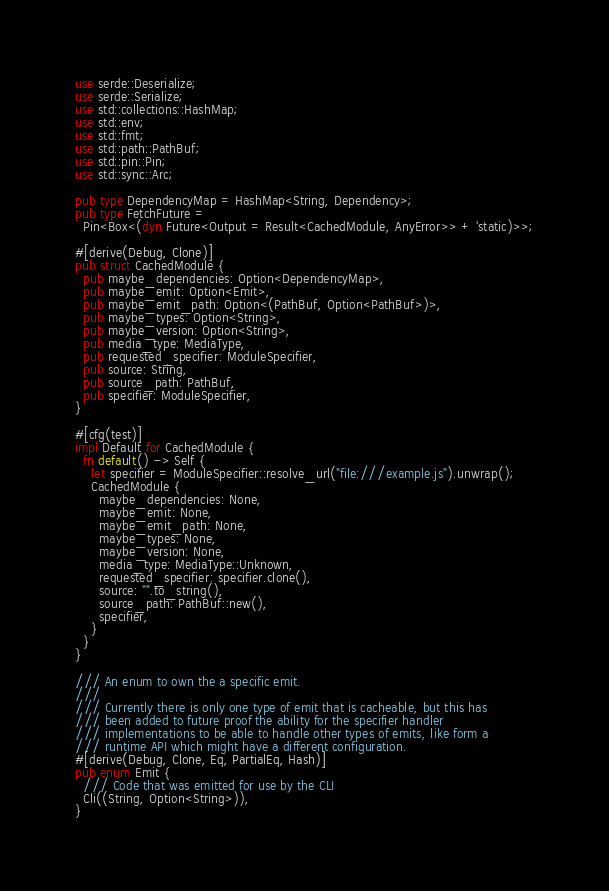Convert code to text. <code><loc_0><loc_0><loc_500><loc_500><_Rust_>use serde::Deserialize;
use serde::Serialize;
use std::collections::HashMap;
use std::env;
use std::fmt;
use std::path::PathBuf;
use std::pin::Pin;
use std::sync::Arc;

pub type DependencyMap = HashMap<String, Dependency>;
pub type FetchFuture =
  Pin<Box<(dyn Future<Output = Result<CachedModule, AnyError>> + 'static)>>;

#[derive(Debug, Clone)]
pub struct CachedModule {
  pub maybe_dependencies: Option<DependencyMap>,
  pub maybe_emit: Option<Emit>,
  pub maybe_emit_path: Option<(PathBuf, Option<PathBuf>)>,
  pub maybe_types: Option<String>,
  pub maybe_version: Option<String>,
  pub media_type: MediaType,
  pub requested_specifier: ModuleSpecifier,
  pub source: String,
  pub source_path: PathBuf,
  pub specifier: ModuleSpecifier,
}

#[cfg(test)]
impl Default for CachedModule {
  fn default() -> Self {
    let specifier = ModuleSpecifier::resolve_url("file:///example.js").unwrap();
    CachedModule {
      maybe_dependencies: None,
      maybe_emit: None,
      maybe_emit_path: None,
      maybe_types: None,
      maybe_version: None,
      media_type: MediaType::Unknown,
      requested_specifier: specifier.clone(),
      source: "".to_string(),
      source_path: PathBuf::new(),
      specifier,
    }
  }
}

/// An enum to own the a specific emit.
///
/// Currently there is only one type of emit that is cacheable, but this has
/// been added to future proof the ability for the specifier handler
/// implementations to be able to handle other types of emits, like form a
/// runtime API which might have a different configuration.
#[derive(Debug, Clone, Eq, PartialEq, Hash)]
pub enum Emit {
  /// Code that was emitted for use by the CLI
  Cli((String, Option<String>)),
}
</code> 